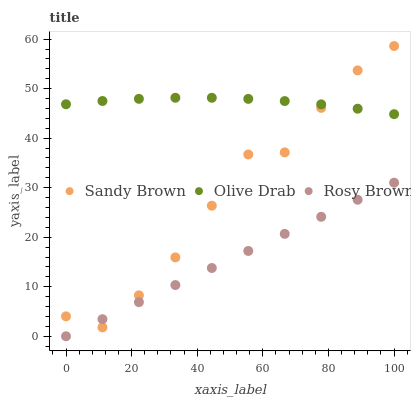Does Rosy Brown have the minimum area under the curve?
Answer yes or no. Yes. Does Olive Drab have the maximum area under the curve?
Answer yes or no. Yes. Does Sandy Brown have the minimum area under the curve?
Answer yes or no. No. Does Sandy Brown have the maximum area under the curve?
Answer yes or no. No. Is Rosy Brown the smoothest?
Answer yes or no. Yes. Is Sandy Brown the roughest?
Answer yes or no. Yes. Is Olive Drab the smoothest?
Answer yes or no. No. Is Olive Drab the roughest?
Answer yes or no. No. Does Rosy Brown have the lowest value?
Answer yes or no. Yes. Does Sandy Brown have the lowest value?
Answer yes or no. No. Does Sandy Brown have the highest value?
Answer yes or no. Yes. Does Olive Drab have the highest value?
Answer yes or no. No. Is Rosy Brown less than Olive Drab?
Answer yes or no. Yes. Is Olive Drab greater than Rosy Brown?
Answer yes or no. Yes. Does Rosy Brown intersect Sandy Brown?
Answer yes or no. Yes. Is Rosy Brown less than Sandy Brown?
Answer yes or no. No. Is Rosy Brown greater than Sandy Brown?
Answer yes or no. No. Does Rosy Brown intersect Olive Drab?
Answer yes or no. No. 